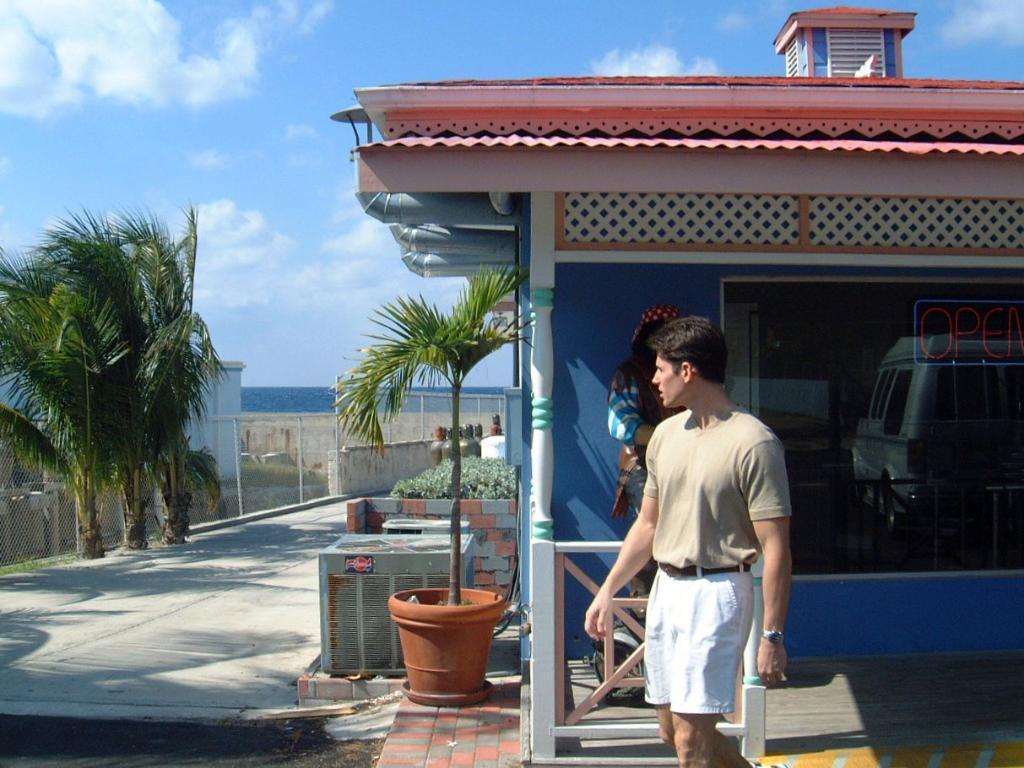Can you describe this image briefly? In this picture we can see two people were a man wore a watch and walking, flower pot with a plant, trees, fence, path, houses, vehicle, pipes and some objects and in the background we can see the sky with clouds. 